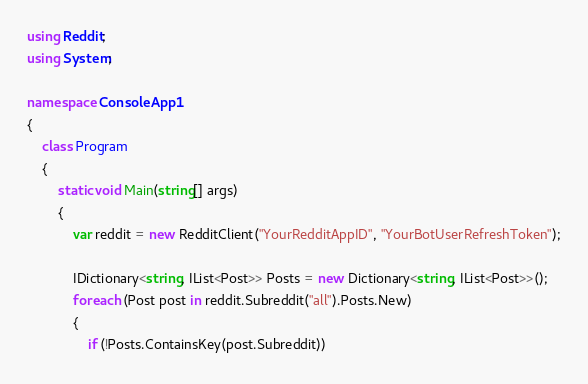<code> <loc_0><loc_0><loc_500><loc_500><_C#_>using Reddit;
using System;

namespace ConsoleApp1
{
    class Program
    {
        static void Main(string[] args)
        {
            var reddit = new RedditClient("YourRedditAppID", "YourBotUserRefreshToken");
			
			IDictionary<string, IList<Post>> Posts = new Dictionary<string, IList<Post>>();
			foreach (Post post in reddit.Subreddit("all").Posts.New)
			{
				if (!Posts.ContainsKey(post.Subreddit))</code> 